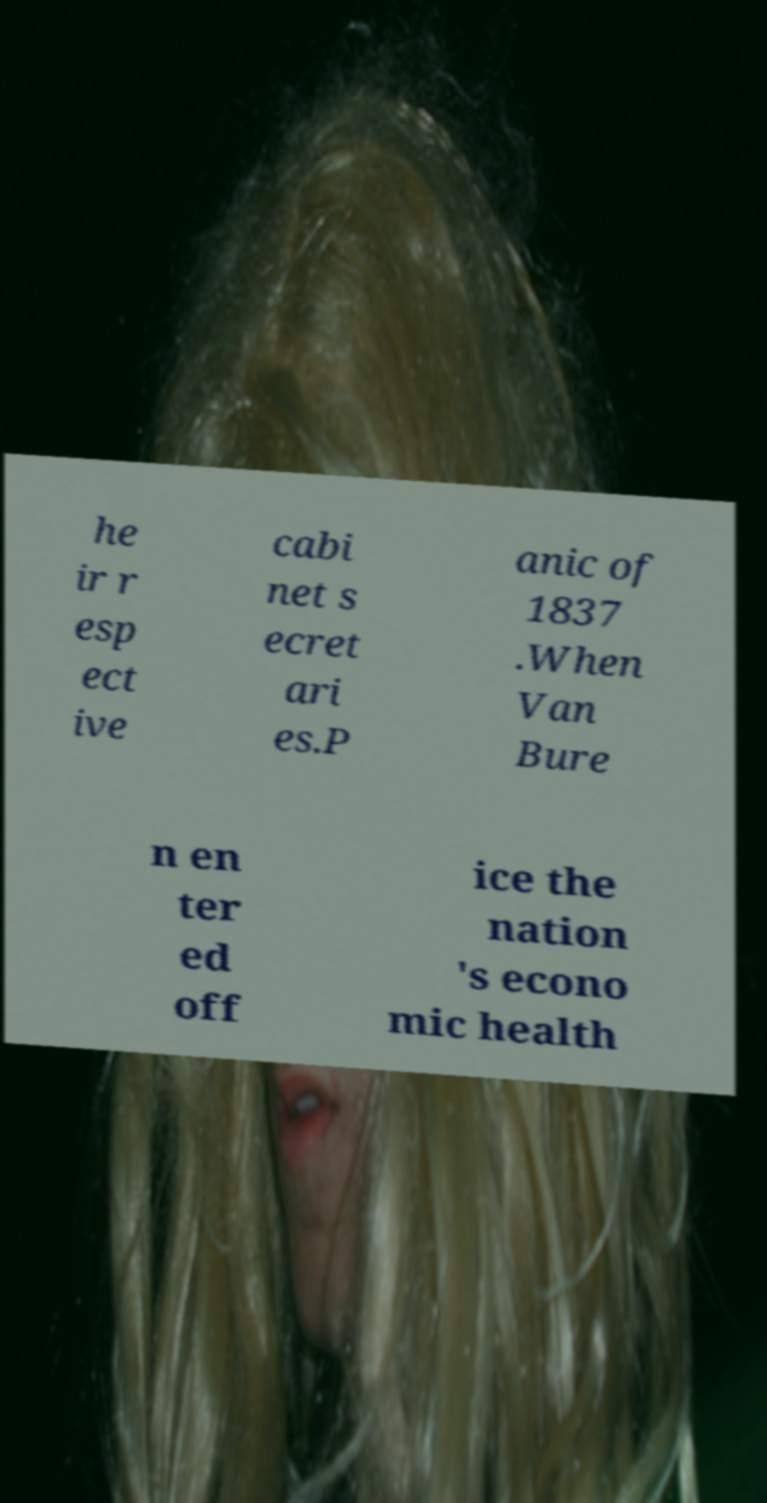I need the written content from this picture converted into text. Can you do that? he ir r esp ect ive cabi net s ecret ari es.P anic of 1837 .When Van Bure n en ter ed off ice the nation 's econo mic health 